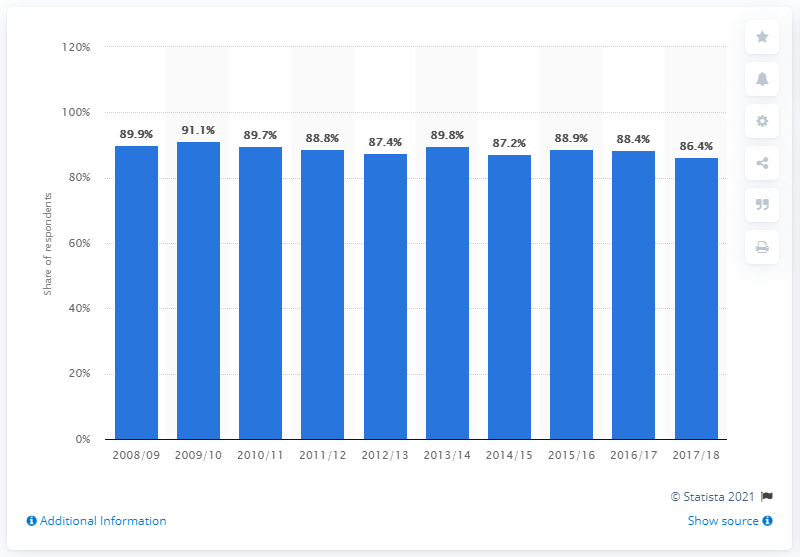Highlight a few significant elements in this photo. The highest participation rate recorded in 2009/2010 was 91.1%. 